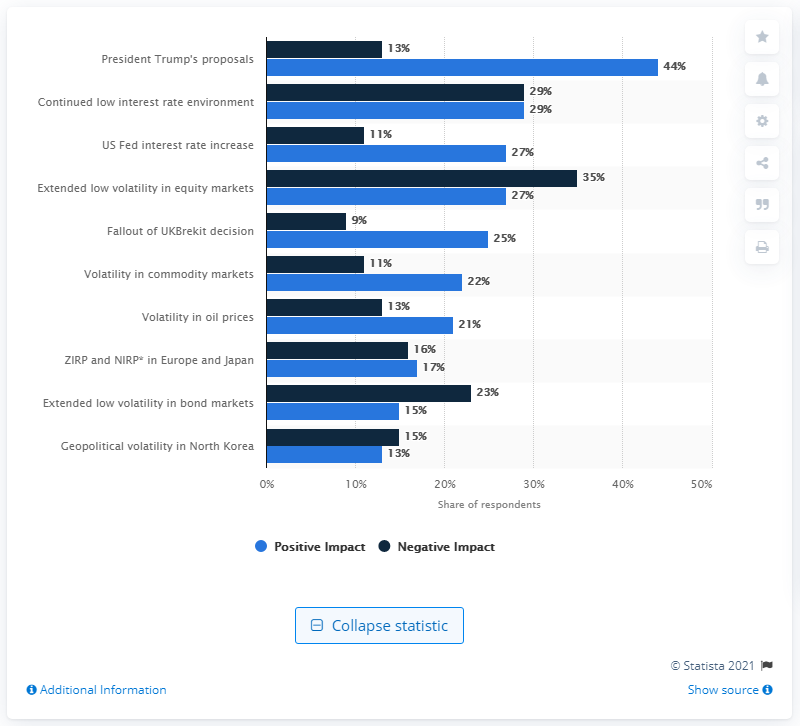Identify some key points in this picture. The sum total percentage of negative and positive impact of respondents in President Trump's proposals factors is 57%. The percentage of positive impact from respondent factors on volatility in oil prices is 21%. 